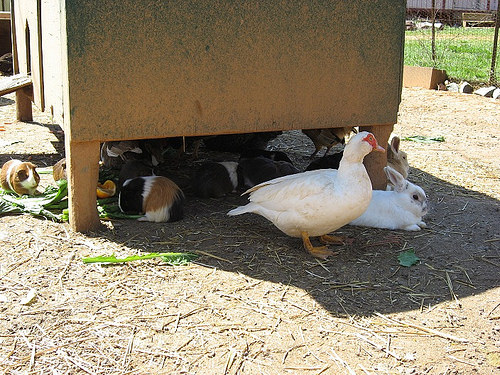<image>
Can you confirm if the rabbit is under the hut? Yes. The rabbit is positioned underneath the hut, with the hut above it in the vertical space. 